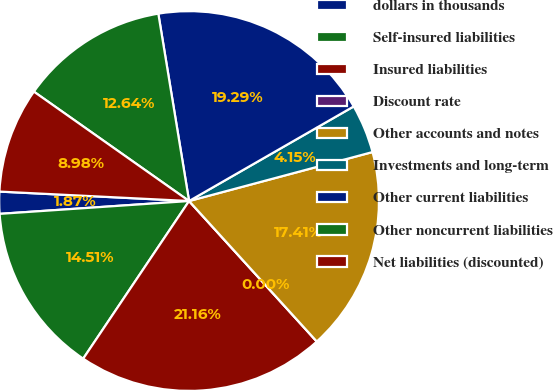Convert chart. <chart><loc_0><loc_0><loc_500><loc_500><pie_chart><fcel>dollars in thousands<fcel>Self-insured liabilities<fcel>Insured liabilities<fcel>Discount rate<fcel>Other accounts and notes<fcel>Investments and long-term<fcel>Other current liabilities<fcel>Other noncurrent liabilities<fcel>Net liabilities (discounted)<nl><fcel>1.87%<fcel>14.51%<fcel>21.16%<fcel>0.0%<fcel>17.41%<fcel>4.15%<fcel>19.29%<fcel>12.64%<fcel>8.98%<nl></chart> 